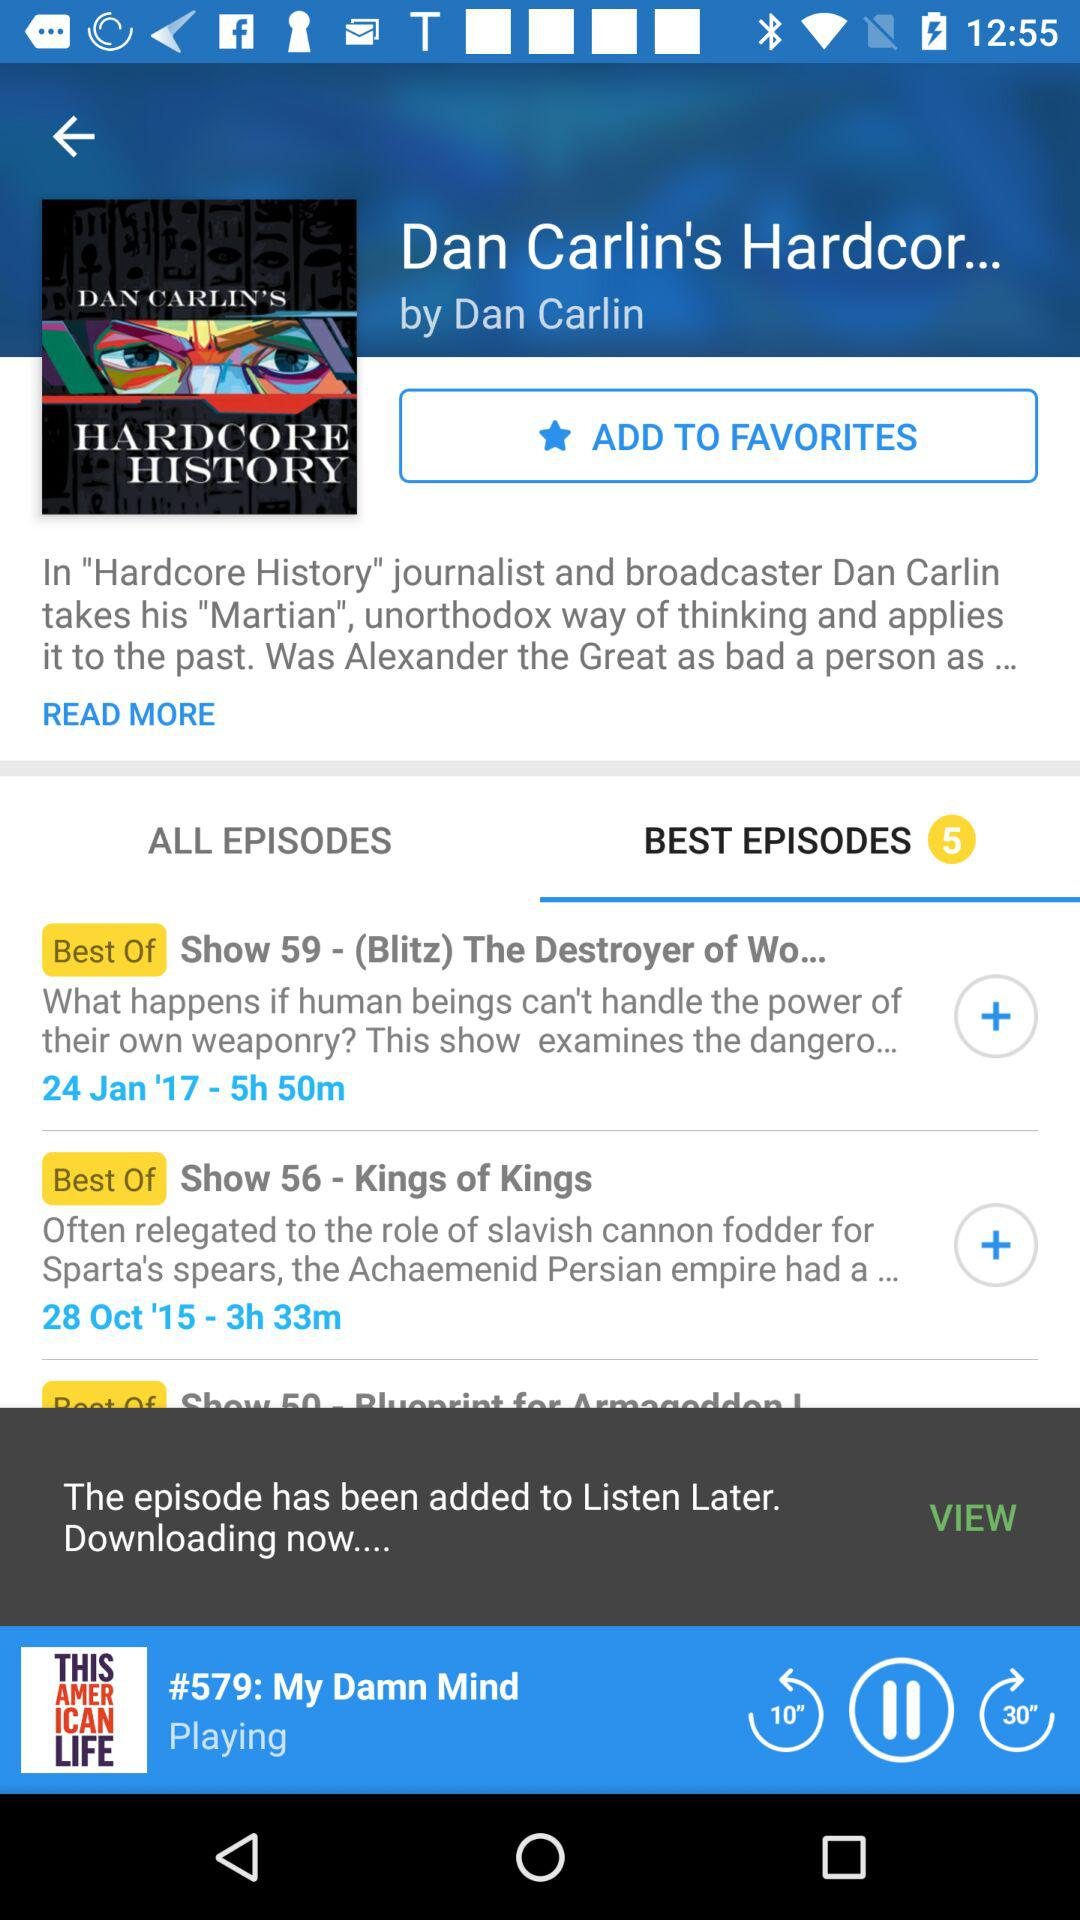What was the date of the "Show 59"? The date of the "Show 59" was January 24, 2017. 